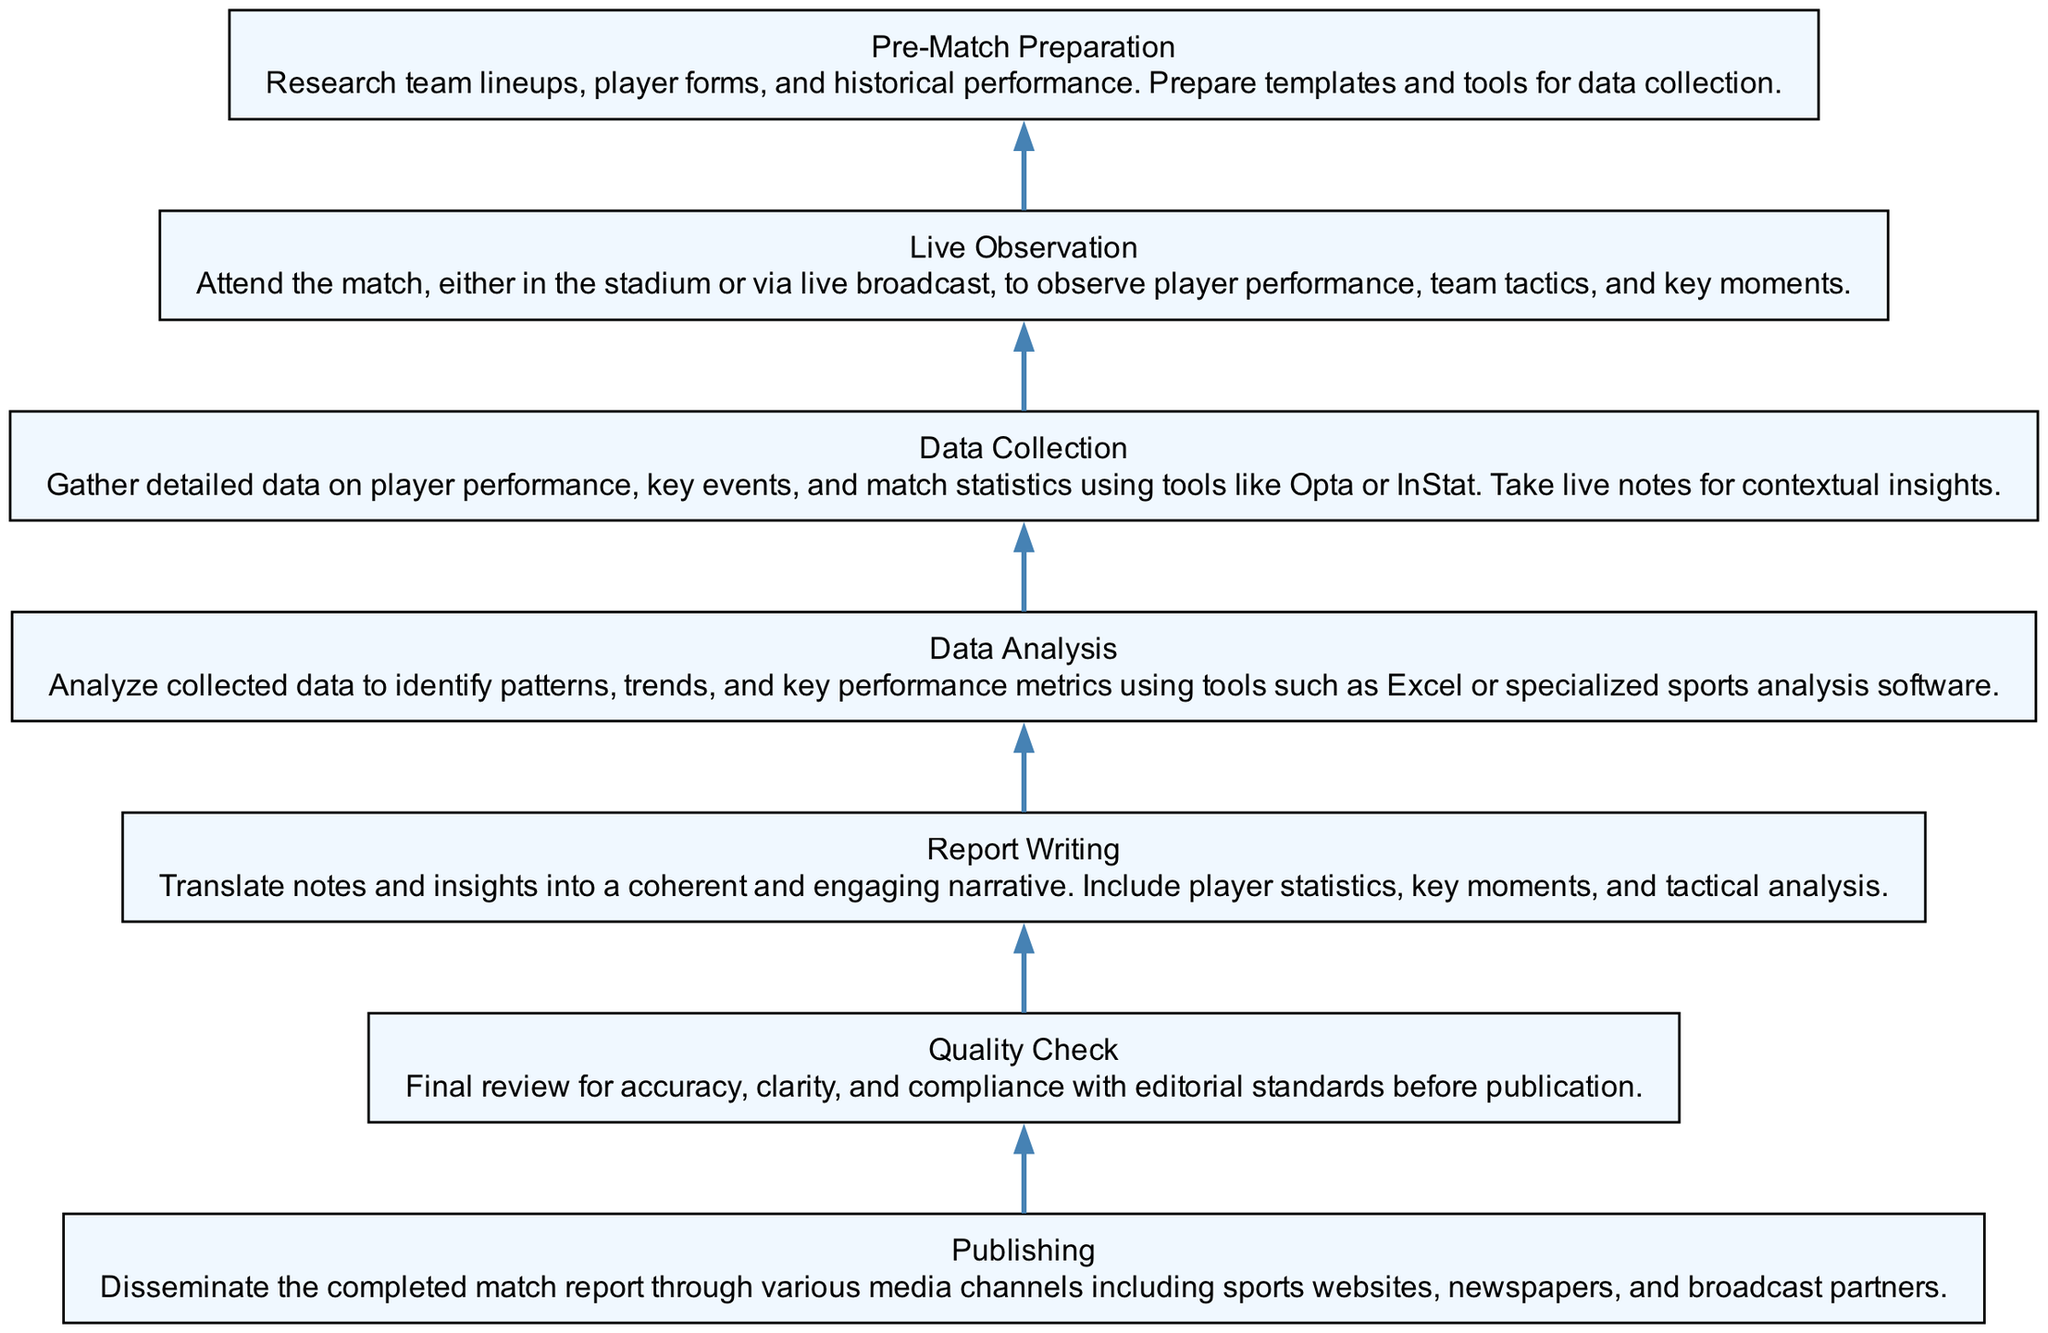What is the final step in the match report development process? The diagram illustrates that the final step in the flow is "Publishing", which involves disseminating the completed match report through various media channels.
Answer: Publishing How many nodes are present in the diagram? Counting all the key elements in the flow chart, there are a total of 7 nodes representing each stage of the match report development process.
Answer: 7 What is the second step from the bottom of the diagram? Following the flow from the bottom upward, the second step is "Data Collection", where detailed data on player performance and match statistics is gathered.
Answer: Data Collection Which step directly precedes the "Quality Check"? According to the flow, "Report Writing" directly precedes "Quality Check", indicating that the narrative is crafted before it is reviewed for accuracy and clarity.
Answer: Report Writing What type of activities occur during the "Live Observation" phase? The "Live Observation" phase involves attending the match and observing player performance, team tactics, and key moments, focusing primarily on in-game dynamics.
Answer: Observing player performance Which step aims to analyze collected data for performance metrics? The "Data Analysis" step is responsible for examining collected data to identify patterns and key performance metrics, using analysis tools.
Answer: Data Analysis What is necessary before proceeding to "Data Collection"? Prior to "Data Collection", "Pre-Match Preparation" is necessary, which includes researching team lineups, player forms, and preparing data collection tools.
Answer: Pre-Match Preparation How are the steps arranged in the diagram? The steps are arranged in a bottom-to-top flow chart format, where each step logically leads to the next, culminating in the final publication of the report.
Answer: Bottom-to-top flow 